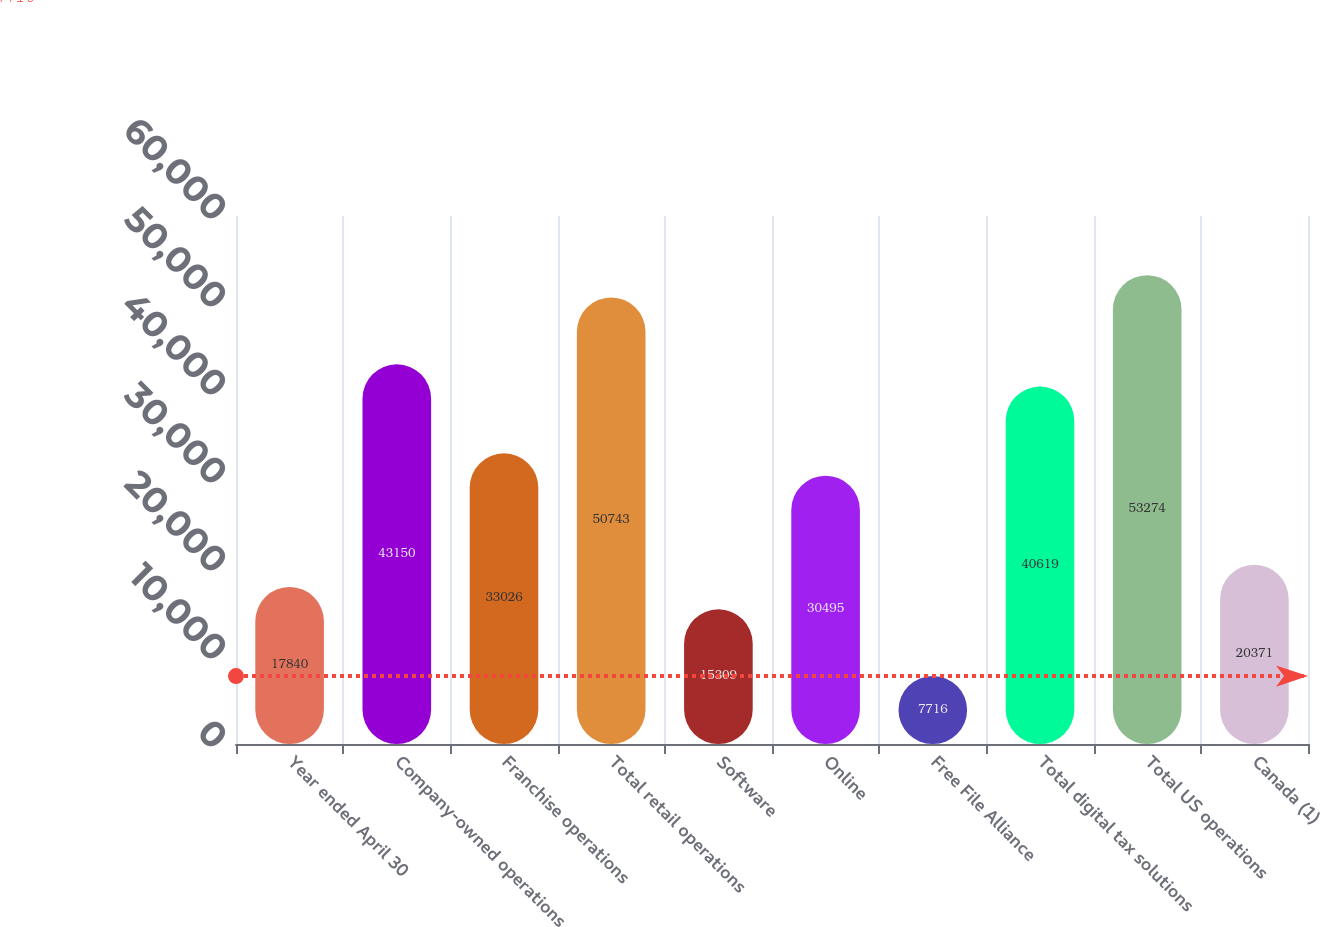Convert chart to OTSL. <chart><loc_0><loc_0><loc_500><loc_500><bar_chart><fcel>Year ended April 30<fcel>Company-owned operations<fcel>Franchise operations<fcel>Total retail operations<fcel>Software<fcel>Online<fcel>Free File Alliance<fcel>Total digital tax solutions<fcel>Total US operations<fcel>Canada (1)<nl><fcel>17840<fcel>43150<fcel>33026<fcel>50743<fcel>15309<fcel>30495<fcel>7716<fcel>40619<fcel>53274<fcel>20371<nl></chart> 